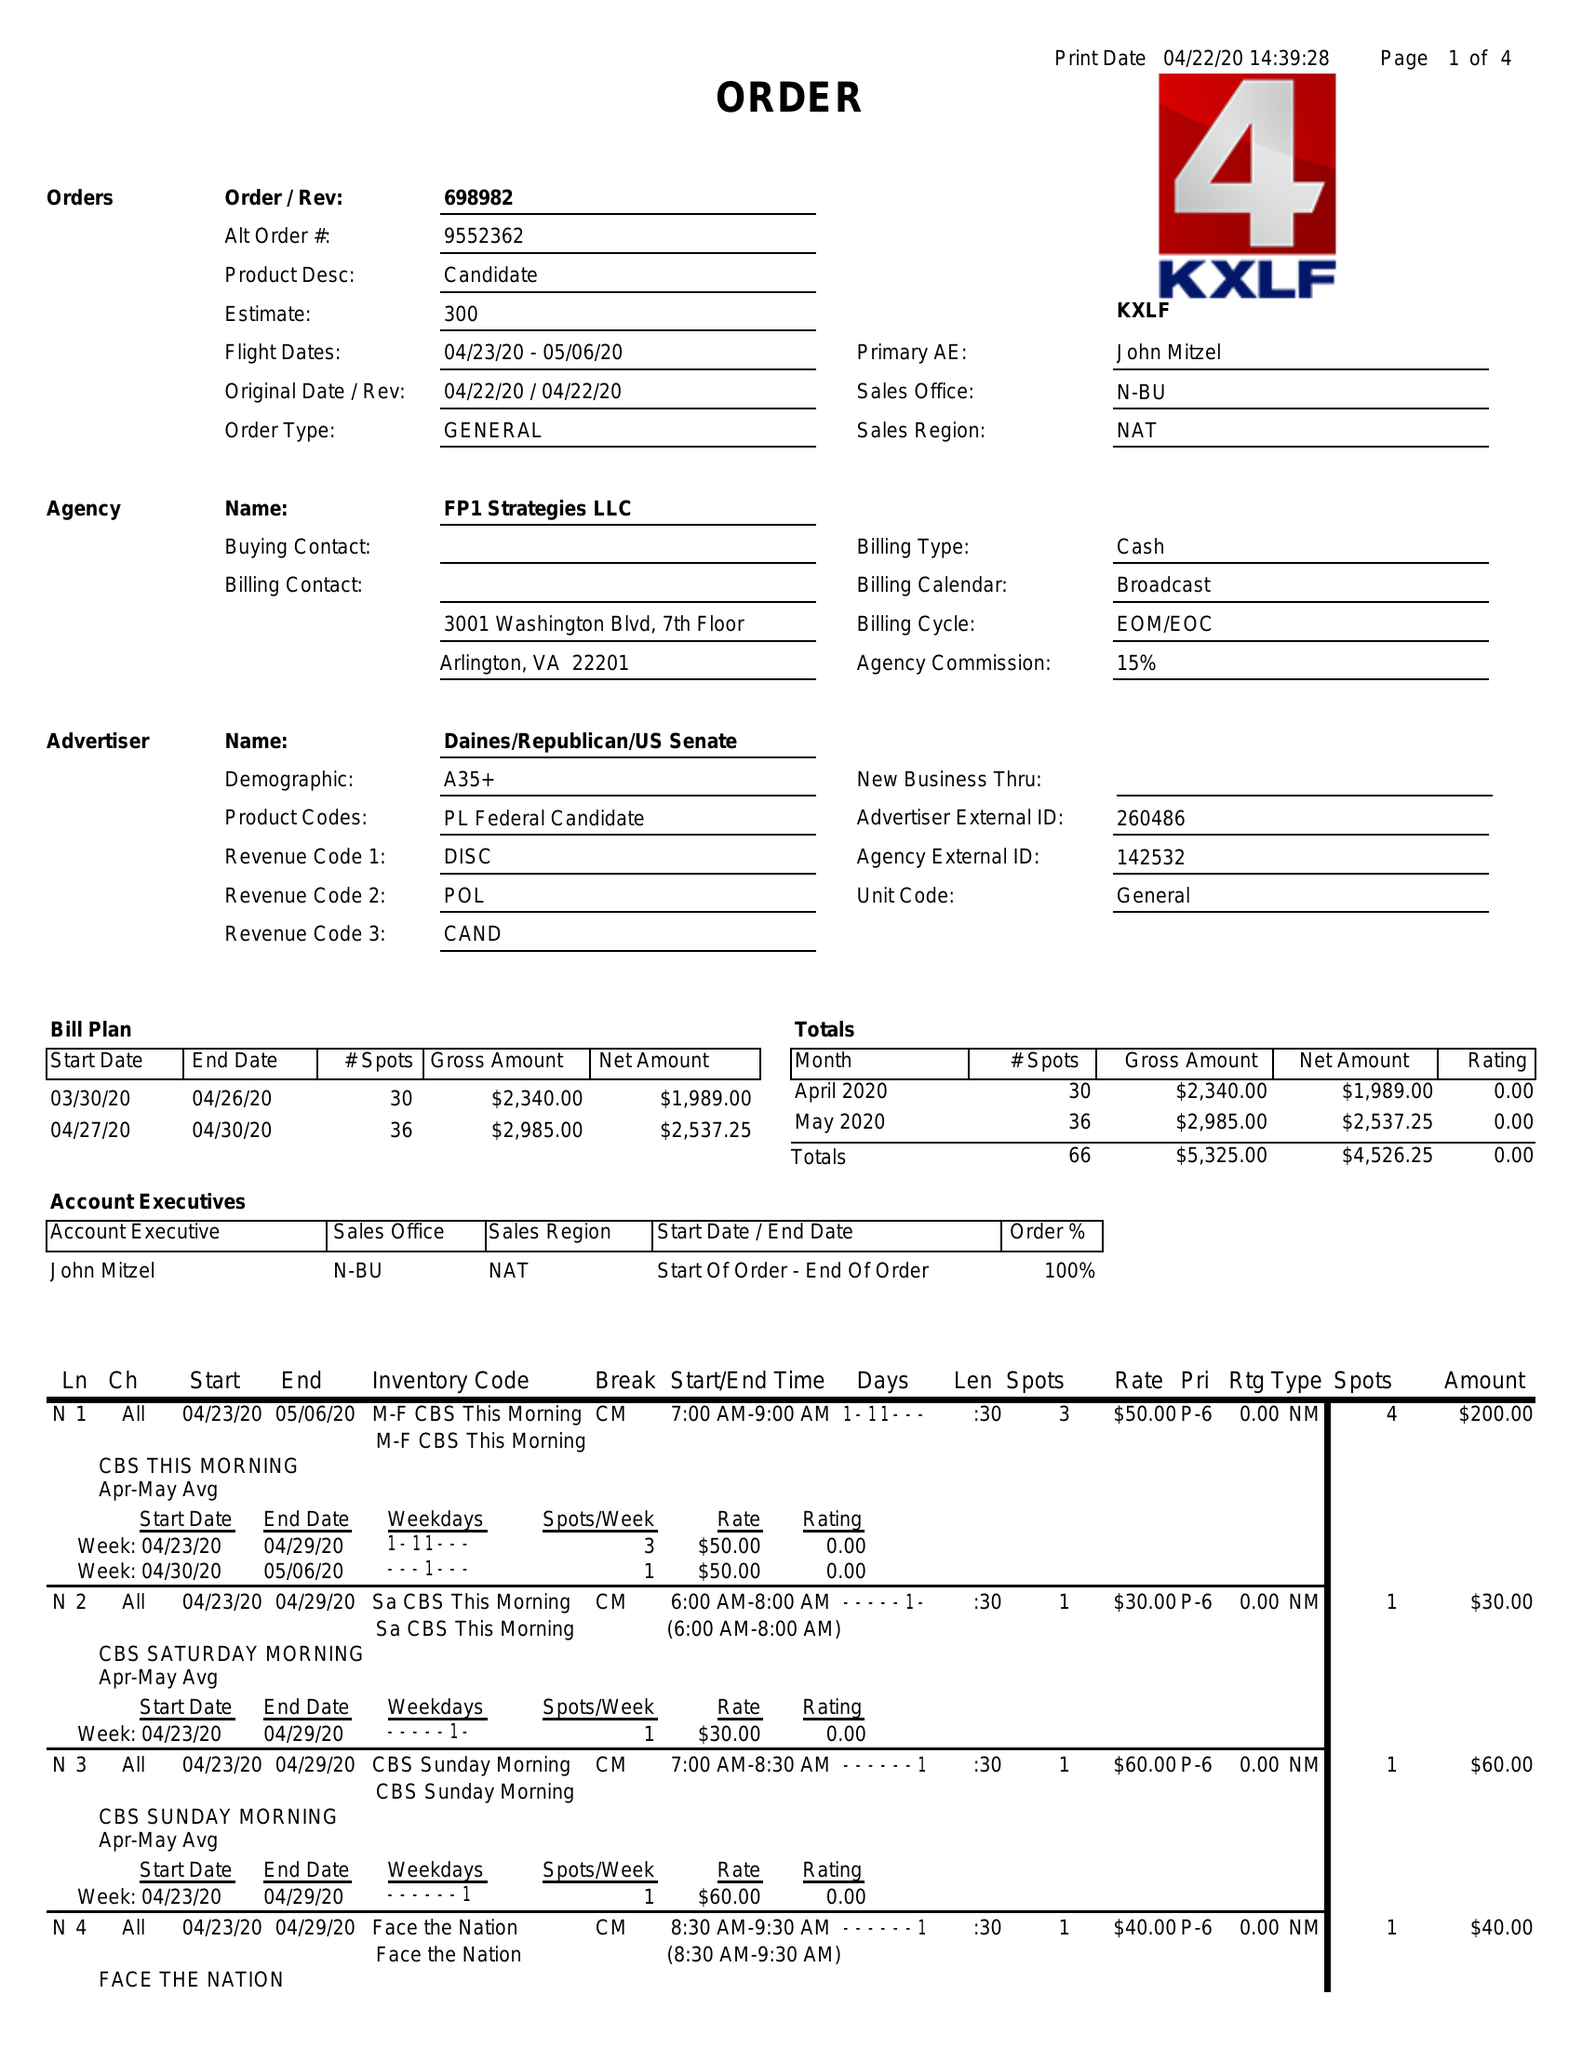What is the value for the contract_num?
Answer the question using a single word or phrase. 698982 